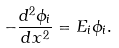Convert formula to latex. <formula><loc_0><loc_0><loc_500><loc_500>- \frac { d ^ { 2 } \phi _ { i } } { d x ^ { 2 } } = E _ { i } \phi _ { i } .</formula> 